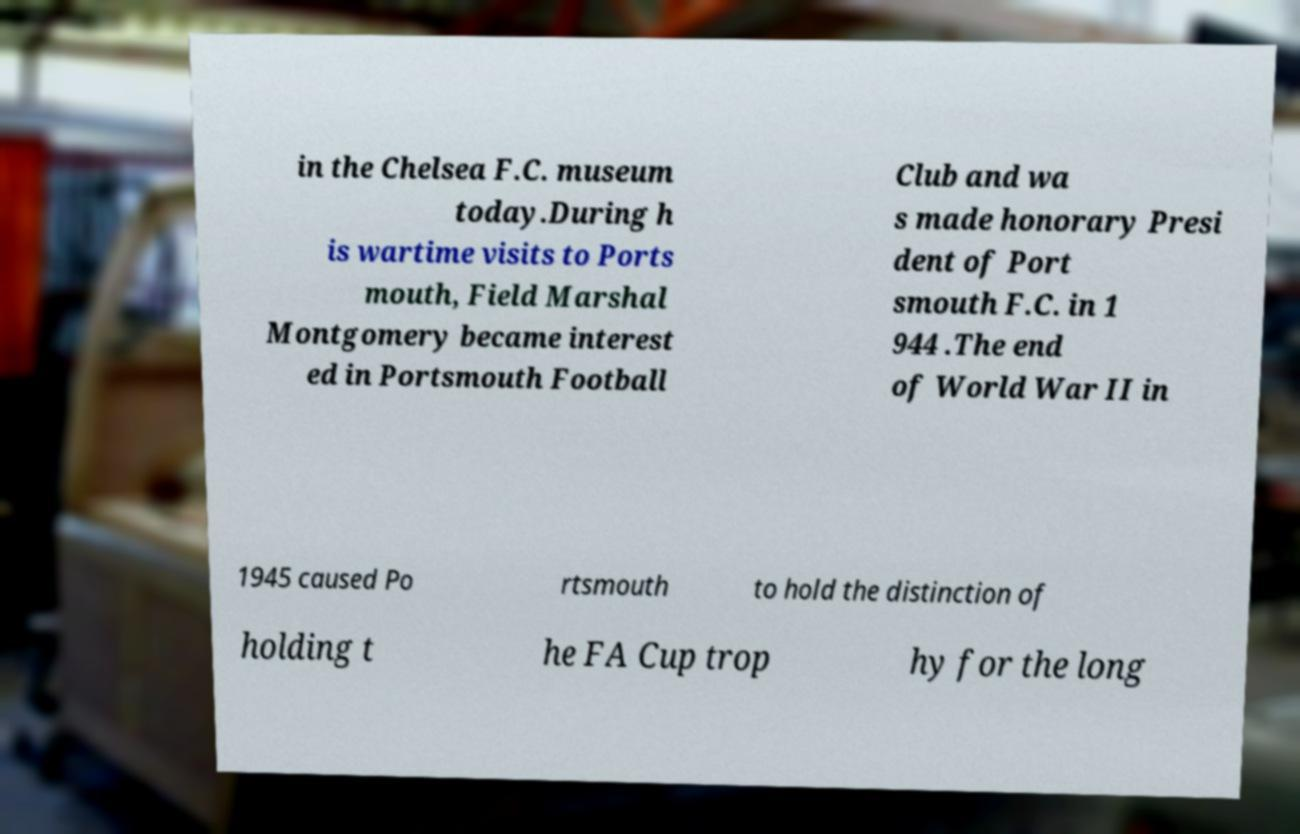I need the written content from this picture converted into text. Can you do that? in the Chelsea F.C. museum today.During h is wartime visits to Ports mouth, Field Marshal Montgomery became interest ed in Portsmouth Football Club and wa s made honorary Presi dent of Port smouth F.C. in 1 944 .The end of World War II in 1945 caused Po rtsmouth to hold the distinction of holding t he FA Cup trop hy for the long 